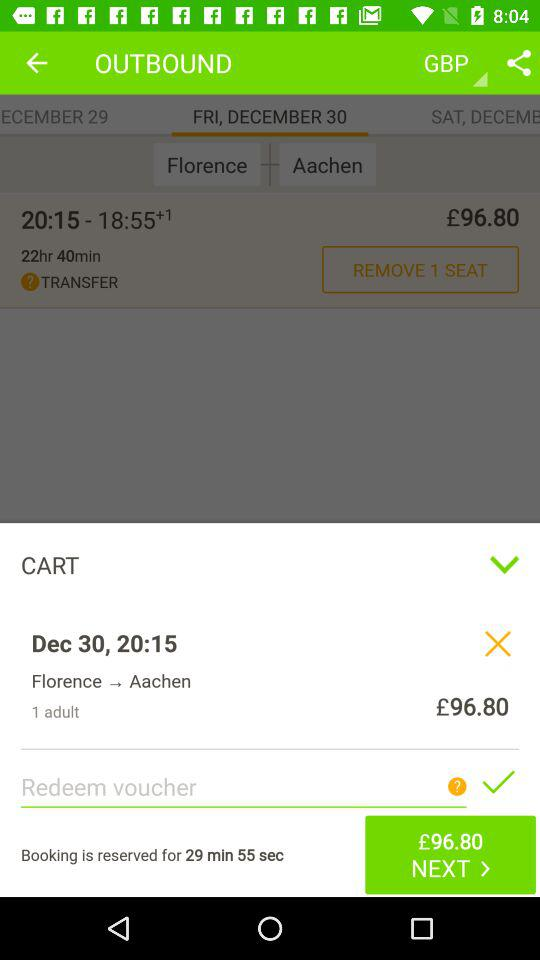How many adults are there? There is 1 adult. 